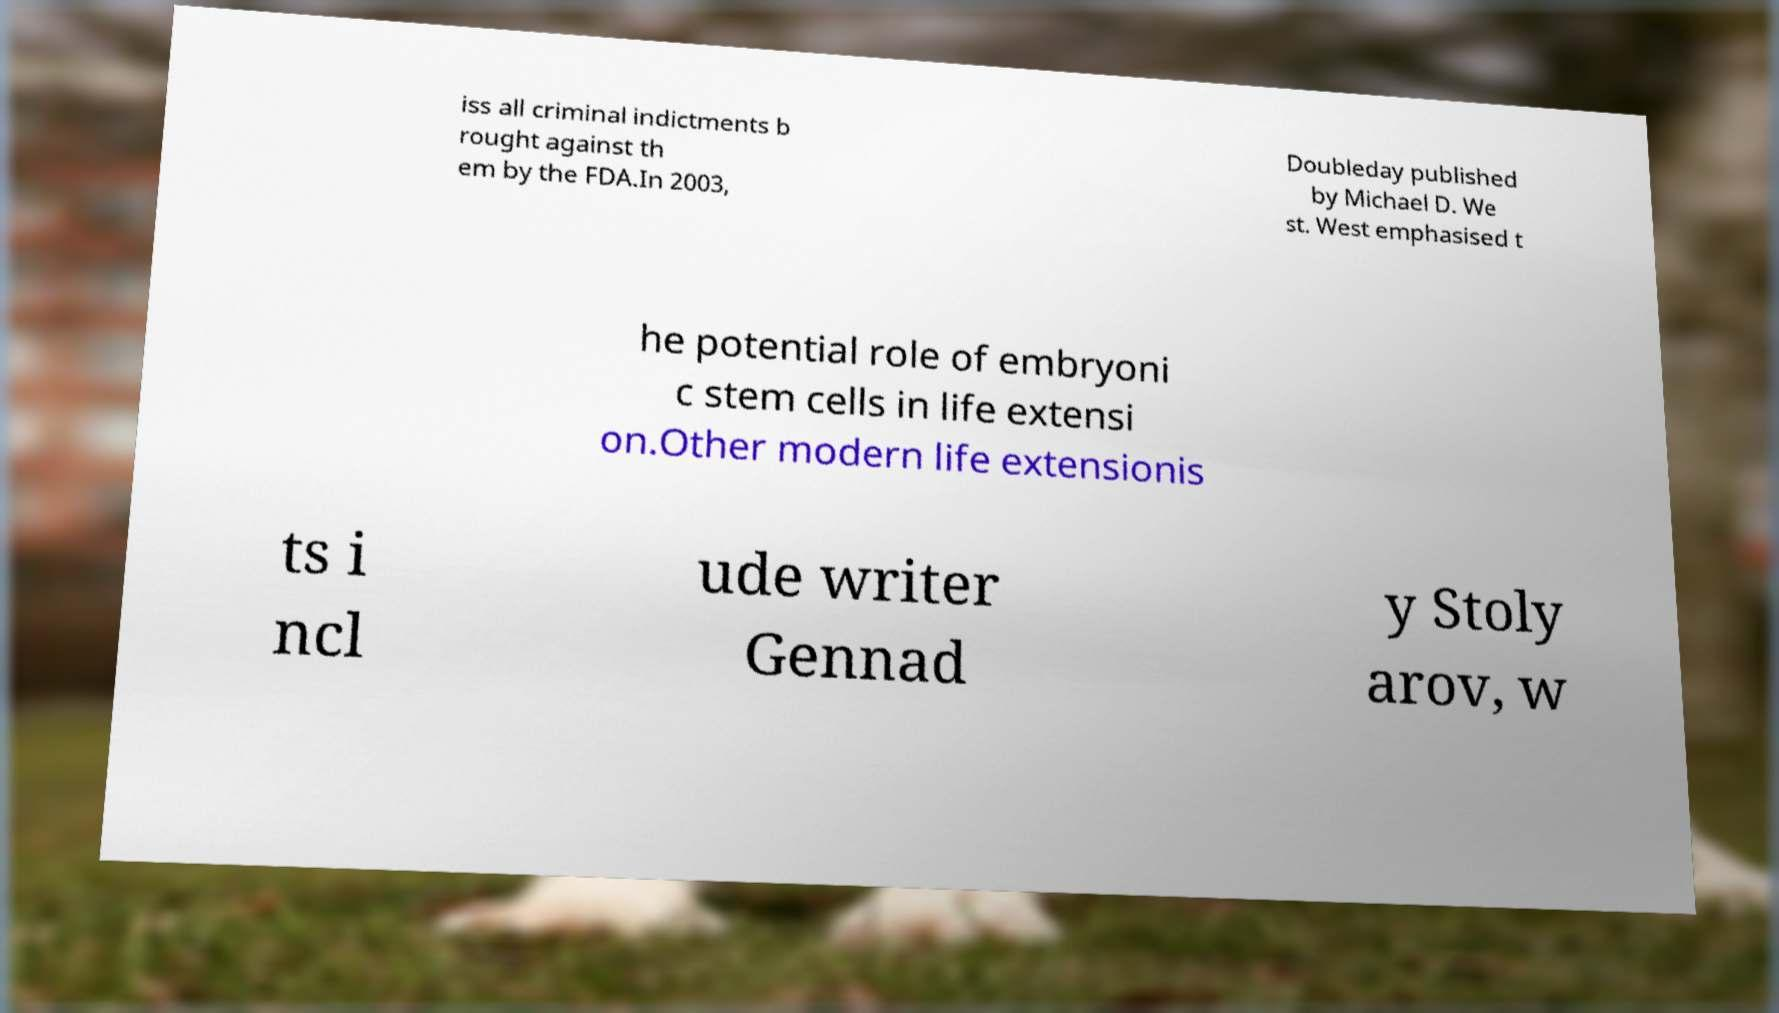Please read and relay the text visible in this image. What does it say? iss all criminal indictments b rought against th em by the FDA.In 2003, Doubleday published by Michael D. We st. West emphasised t he potential role of embryoni c stem cells in life extensi on.Other modern life extensionis ts i ncl ude writer Gennad y Stoly arov, w 